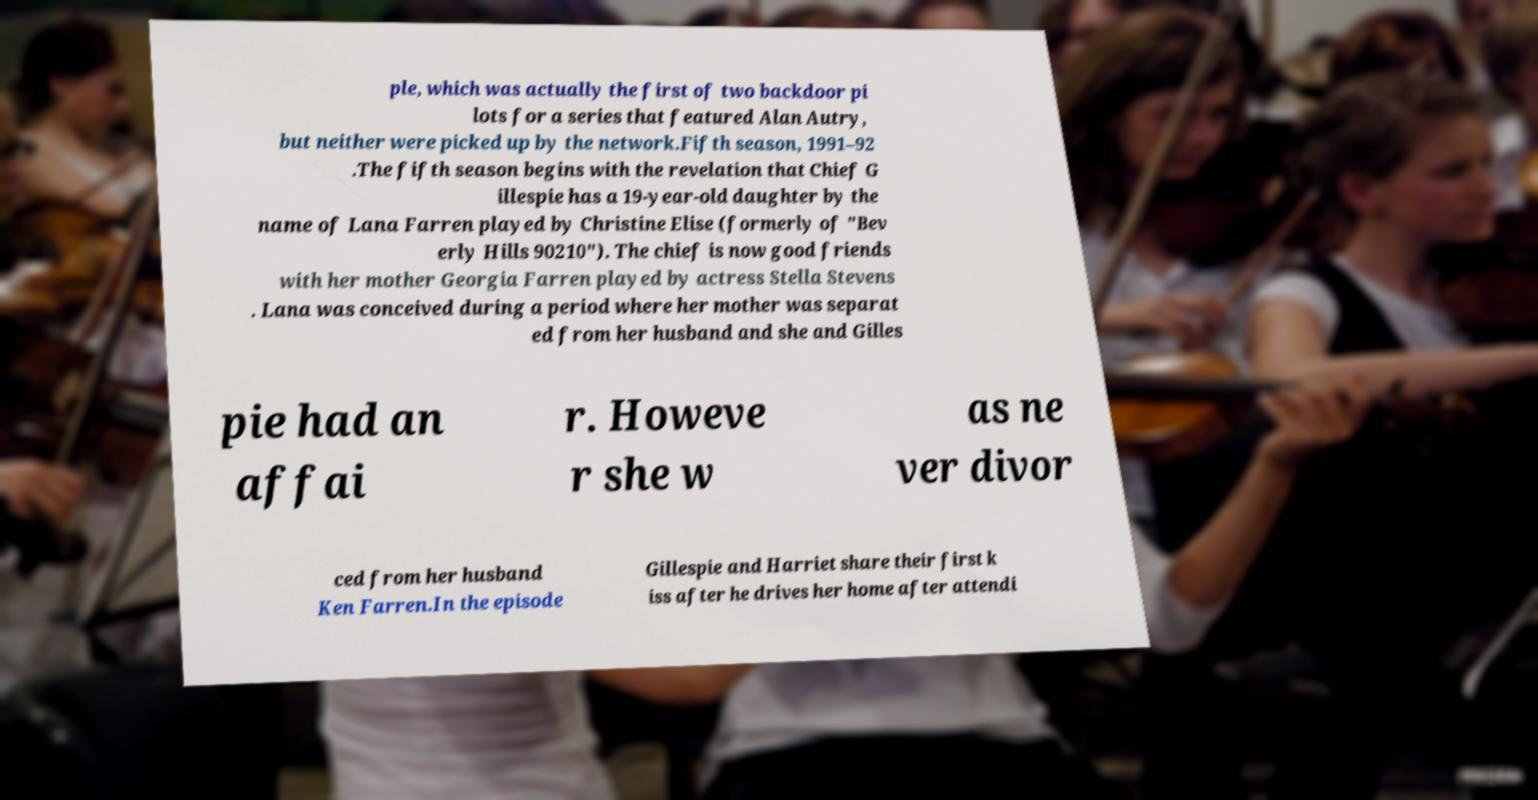Can you accurately transcribe the text from the provided image for me? ple, which was actually the first of two backdoor pi lots for a series that featured Alan Autry, but neither were picked up by the network.Fifth season, 1991–92 .The fifth season begins with the revelation that Chief G illespie has a 19-year-old daughter by the name of Lana Farren played by Christine Elise (formerly of "Bev erly Hills 90210"). The chief is now good friends with her mother Georgia Farren played by actress Stella Stevens . Lana was conceived during a period where her mother was separat ed from her husband and she and Gilles pie had an affai r. Howeve r she w as ne ver divor ced from her husband Ken Farren.In the episode Gillespie and Harriet share their first k iss after he drives her home after attendi 